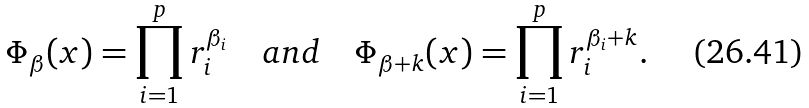<formula> <loc_0><loc_0><loc_500><loc_500>\Phi _ { \beta } ( x ) = \prod _ { i = 1 } ^ { p } r _ { i } ^ { \beta _ { i } } \quad a n d \quad \Phi _ { \beta + k } ( x ) = \prod _ { i = 1 } ^ { p } r _ { i } ^ { \beta _ { i } + k } .</formula> 